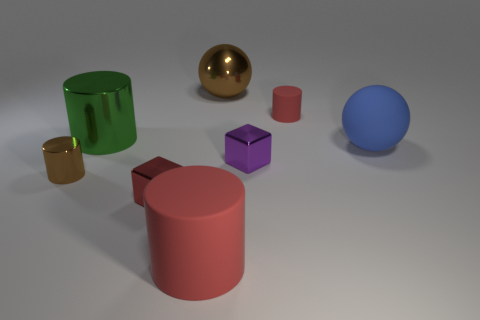What number of other objects are there of the same size as the brown ball?
Give a very brief answer. 3. There is a brown metal thing on the right side of the big matte object in front of the large blue matte ball; what size is it?
Your response must be concise. Large. What number of small things are blue rubber objects or spheres?
Give a very brief answer. 0. There is a sphere that is in front of the red thing behind the sphere that is in front of the big green metal cylinder; what size is it?
Offer a very short reply. Large. Is there any other thing that is the same color as the large rubber cylinder?
Provide a succinct answer. Yes. What material is the small red object that is to the left of the rubber object that is left of the large ball behind the large green cylinder made of?
Your response must be concise. Metal. Is the blue object the same shape as the big brown object?
Your answer should be very brief. Yes. How many shiny things are in front of the big blue matte object and behind the large blue matte sphere?
Provide a succinct answer. 0. What is the color of the rubber thing that is in front of the tiny cube that is right of the brown metal ball?
Keep it short and to the point. Red. Are there the same number of red matte cylinders that are in front of the matte ball and small purple cubes?
Offer a very short reply. Yes. 